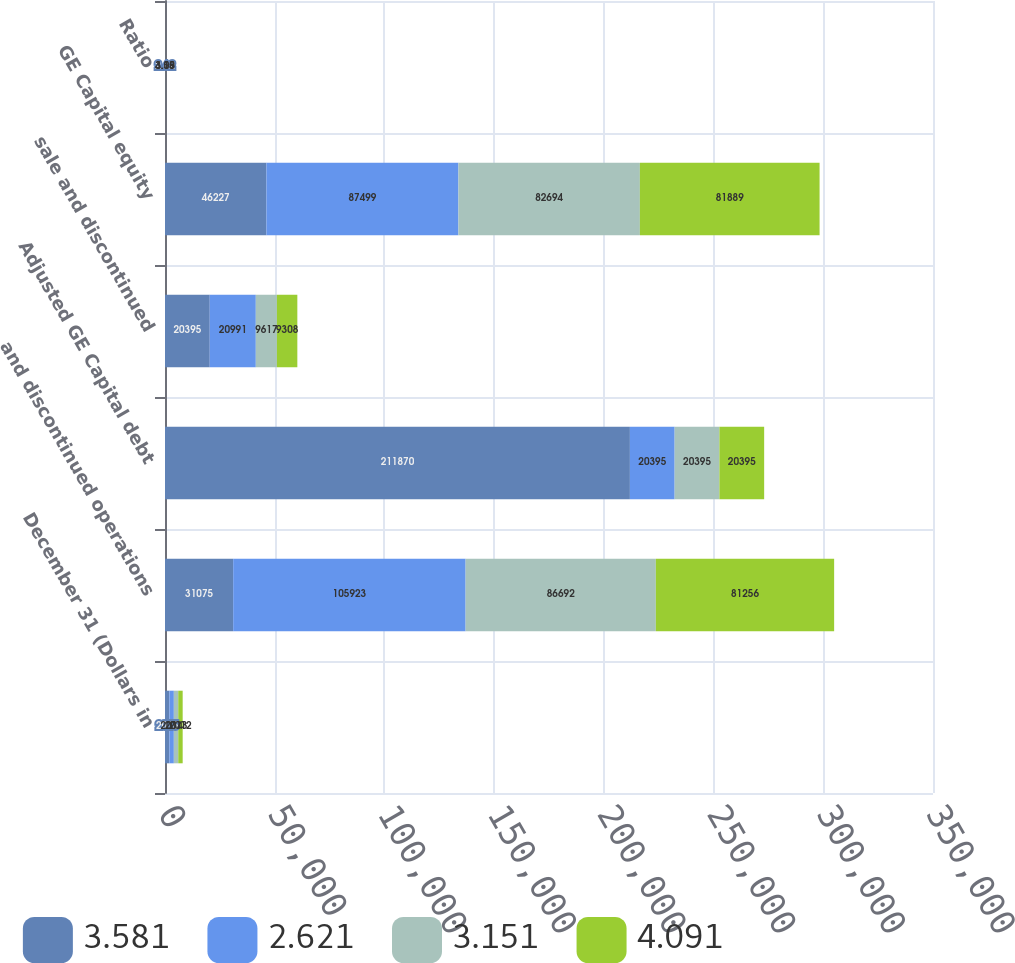<chart> <loc_0><loc_0><loc_500><loc_500><stacked_bar_chart><ecel><fcel>December 31 (Dollars in<fcel>and discontinued operations<fcel>Adjusted GE Capital debt<fcel>sale and discontinued<fcel>GE Capital equity<fcel>Ratio<nl><fcel>3.581<fcel>2015<fcel>31075<fcel>211870<fcel>20395<fcel>46227<fcel>2.62<nl><fcel>2.621<fcel>2014<fcel>105923<fcel>20395<fcel>20991<fcel>87499<fcel>3.15<nl><fcel>3.151<fcel>2013<fcel>86692<fcel>20395<fcel>9617<fcel>82694<fcel>3.58<nl><fcel>4.091<fcel>2012<fcel>81256<fcel>20395<fcel>9308<fcel>81889<fcel>4.09<nl></chart> 